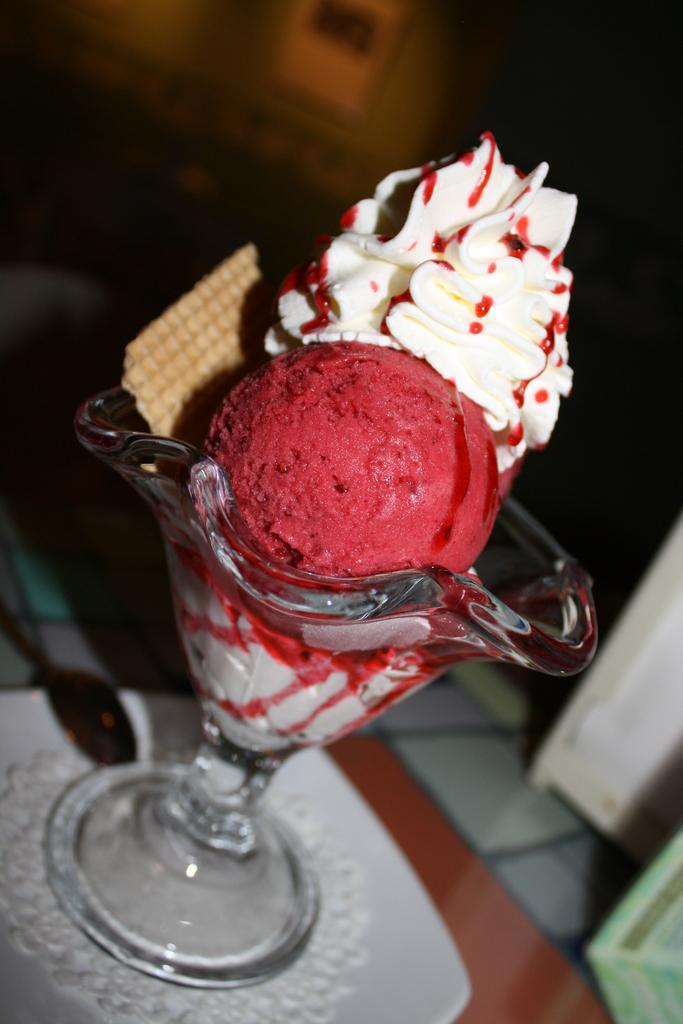What type of dessert is in the image? There is ice cream in a cup in the image. Can you describe the background of the image? The background of the image is blurry. What type of fear can be seen on the pig's face in the image? There is no pig present in the image, and therefore no fear can be observed. What type of brass object is visible in the image? There is no brass object present in the image. 